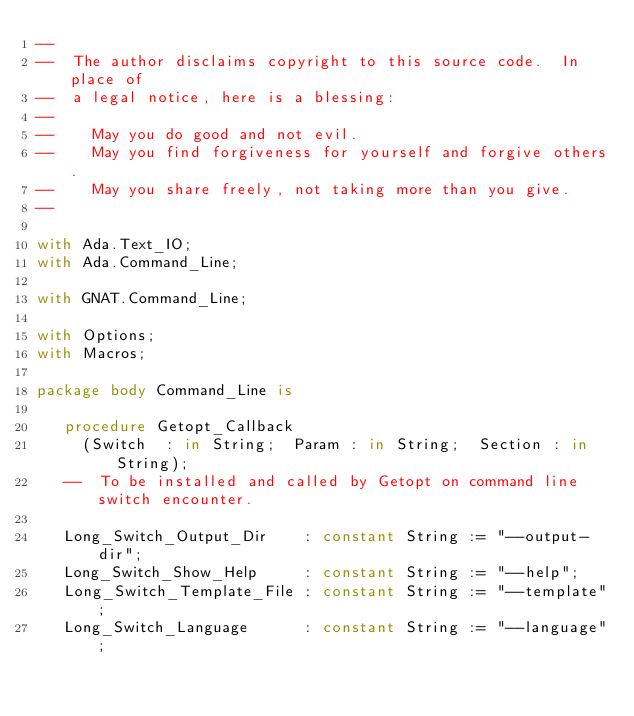Convert code to text. <code><loc_0><loc_0><loc_500><loc_500><_Ada_>--
--  The author disclaims copyright to this source code.  In place of
--  a legal notice, here is a blessing:
--
--    May you do good and not evil.
--    May you find forgiveness for yourself and forgive others.
--    May you share freely, not taking more than you give.
--

with Ada.Text_IO;
with Ada.Command_Line;

with GNAT.Command_Line;

with Options;
with Macros;

package body Command_Line is

   procedure Getopt_Callback
     (Switch  : in String;  Param : in String;  Section : in String);
   --  To be installed and called by Getopt on command line switch encounter.

   Long_Switch_Output_Dir    : constant String := "--output-dir";
   Long_Switch_Show_Help     : constant String := "--help";
   Long_Switch_Template_File : constant String := "--template";
   Long_Switch_Language      : constant String := "--language";</code> 